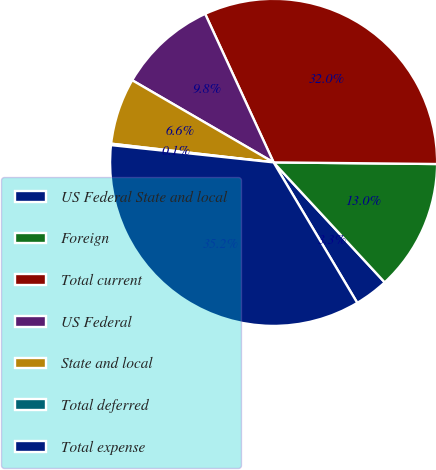<chart> <loc_0><loc_0><loc_500><loc_500><pie_chart><fcel>US Federal State and local<fcel>Foreign<fcel>Total current<fcel>US Federal<fcel>State and local<fcel>Total deferred<fcel>Total expense<nl><fcel>3.34%<fcel>12.95%<fcel>32.03%<fcel>9.75%<fcel>6.55%<fcel>0.14%<fcel>35.23%<nl></chart> 